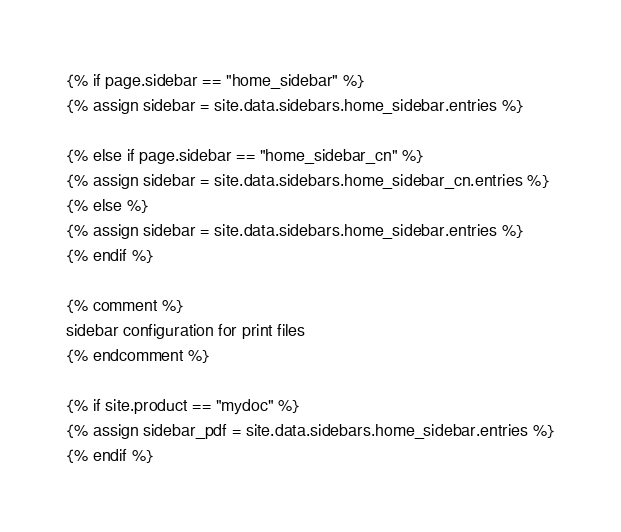<code> <loc_0><loc_0><loc_500><loc_500><_HTML_>{% if page.sidebar == "home_sidebar" %}
{% assign sidebar = site.data.sidebars.home_sidebar.entries %}

{% else if page.sidebar == "home_sidebar_cn" %}
{% assign sidebar = site.data.sidebars.home_sidebar_cn.entries %}
{% else %}
{% assign sidebar = site.data.sidebars.home_sidebar.entries %}
{% endif %}

{% comment %}
sidebar configuration for print files
{% endcomment %}

{% if site.product == "mydoc" %}
{% assign sidebar_pdf = site.data.sidebars.home_sidebar.entries %}
{% endif %}

</code> 